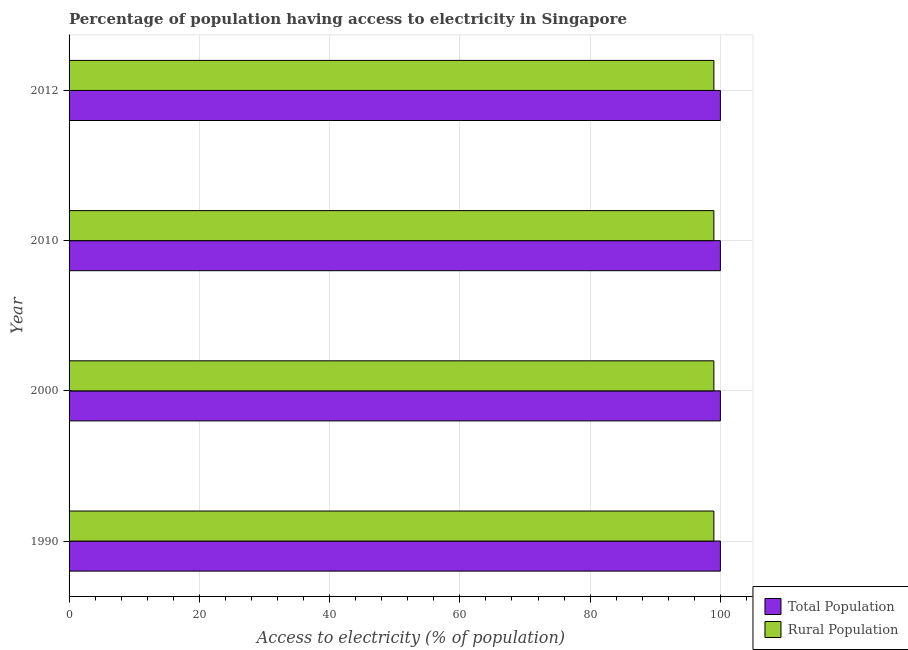How many different coloured bars are there?
Provide a short and direct response. 2. How many groups of bars are there?
Your response must be concise. 4. Are the number of bars on each tick of the Y-axis equal?
Provide a short and direct response. Yes. How many bars are there on the 1st tick from the top?
Offer a terse response. 2. What is the percentage of population having access to electricity in 1990?
Your answer should be compact. 100. Across all years, what is the maximum percentage of population having access to electricity?
Offer a very short reply. 100. Across all years, what is the minimum percentage of rural population having access to electricity?
Make the answer very short. 99. In which year was the percentage of population having access to electricity maximum?
Your response must be concise. 1990. In which year was the percentage of population having access to electricity minimum?
Your answer should be very brief. 1990. What is the total percentage of rural population having access to electricity in the graph?
Make the answer very short. 396. What is the difference between the percentage of population having access to electricity in 1990 and that in 2012?
Make the answer very short. 0. What is the difference between the percentage of rural population having access to electricity in 2000 and the percentage of population having access to electricity in 2010?
Provide a short and direct response. -1. In the year 2000, what is the difference between the percentage of population having access to electricity and percentage of rural population having access to electricity?
Your response must be concise. 1. In how many years, is the percentage of rural population having access to electricity greater than 60 %?
Provide a short and direct response. 4. What is the ratio of the percentage of population having access to electricity in 1990 to that in 2010?
Your answer should be compact. 1. Is the percentage of population having access to electricity in 1990 less than that in 2010?
Offer a terse response. No. What does the 1st bar from the top in 2010 represents?
Make the answer very short. Rural Population. What does the 1st bar from the bottom in 2010 represents?
Make the answer very short. Total Population. Are all the bars in the graph horizontal?
Your answer should be very brief. Yes. What is the difference between two consecutive major ticks on the X-axis?
Ensure brevity in your answer.  20. Does the graph contain any zero values?
Your answer should be very brief. No. Does the graph contain grids?
Your answer should be very brief. Yes. How are the legend labels stacked?
Provide a short and direct response. Vertical. What is the title of the graph?
Your answer should be compact. Percentage of population having access to electricity in Singapore. What is the label or title of the X-axis?
Offer a very short reply. Access to electricity (% of population). What is the Access to electricity (% of population) in Total Population in 2010?
Your response must be concise. 100. What is the Access to electricity (% of population) in Total Population in 2012?
Your answer should be compact. 100. Across all years, what is the maximum Access to electricity (% of population) in Total Population?
Provide a succinct answer. 100. Across all years, what is the maximum Access to electricity (% of population) in Rural Population?
Keep it short and to the point. 99. What is the total Access to electricity (% of population) of Rural Population in the graph?
Your answer should be very brief. 396. What is the difference between the Access to electricity (% of population) of Rural Population in 1990 and that in 2000?
Your response must be concise. 0. What is the difference between the Access to electricity (% of population) in Total Population in 1990 and that in 2010?
Give a very brief answer. 0. What is the difference between the Access to electricity (% of population) of Rural Population in 1990 and that in 2012?
Your answer should be very brief. 0. What is the difference between the Access to electricity (% of population) of Rural Population in 2000 and that in 2010?
Provide a short and direct response. 0. What is the difference between the Access to electricity (% of population) of Total Population in 2000 and that in 2012?
Your answer should be very brief. 0. What is the difference between the Access to electricity (% of population) of Rural Population in 2000 and that in 2012?
Keep it short and to the point. 0. What is the difference between the Access to electricity (% of population) in Total Population in 1990 and the Access to electricity (% of population) in Rural Population in 2000?
Keep it short and to the point. 1. What is the difference between the Access to electricity (% of population) in Total Population in 1990 and the Access to electricity (% of population) in Rural Population in 2012?
Your answer should be very brief. 1. What is the difference between the Access to electricity (% of population) of Total Population in 2000 and the Access to electricity (% of population) of Rural Population in 2010?
Your response must be concise. 1. What is the difference between the Access to electricity (% of population) of Total Population in 2010 and the Access to electricity (% of population) of Rural Population in 2012?
Provide a succinct answer. 1. What is the average Access to electricity (% of population) in Total Population per year?
Your answer should be compact. 100. What is the average Access to electricity (% of population) in Rural Population per year?
Keep it short and to the point. 99. What is the ratio of the Access to electricity (% of population) in Total Population in 1990 to that in 2000?
Make the answer very short. 1. What is the ratio of the Access to electricity (% of population) of Total Population in 1990 to that in 2010?
Offer a very short reply. 1. What is the ratio of the Access to electricity (% of population) of Total Population in 1990 to that in 2012?
Provide a succinct answer. 1. What is the ratio of the Access to electricity (% of population) in Rural Population in 1990 to that in 2012?
Offer a terse response. 1. What is the ratio of the Access to electricity (% of population) in Rural Population in 2000 to that in 2010?
Provide a short and direct response. 1. What is the ratio of the Access to electricity (% of population) in Total Population in 2010 to that in 2012?
Ensure brevity in your answer.  1. What is the ratio of the Access to electricity (% of population) of Rural Population in 2010 to that in 2012?
Offer a very short reply. 1. What is the difference between the highest and the second highest Access to electricity (% of population) of Total Population?
Offer a terse response. 0. What is the difference between the highest and the second highest Access to electricity (% of population) of Rural Population?
Keep it short and to the point. 0. 